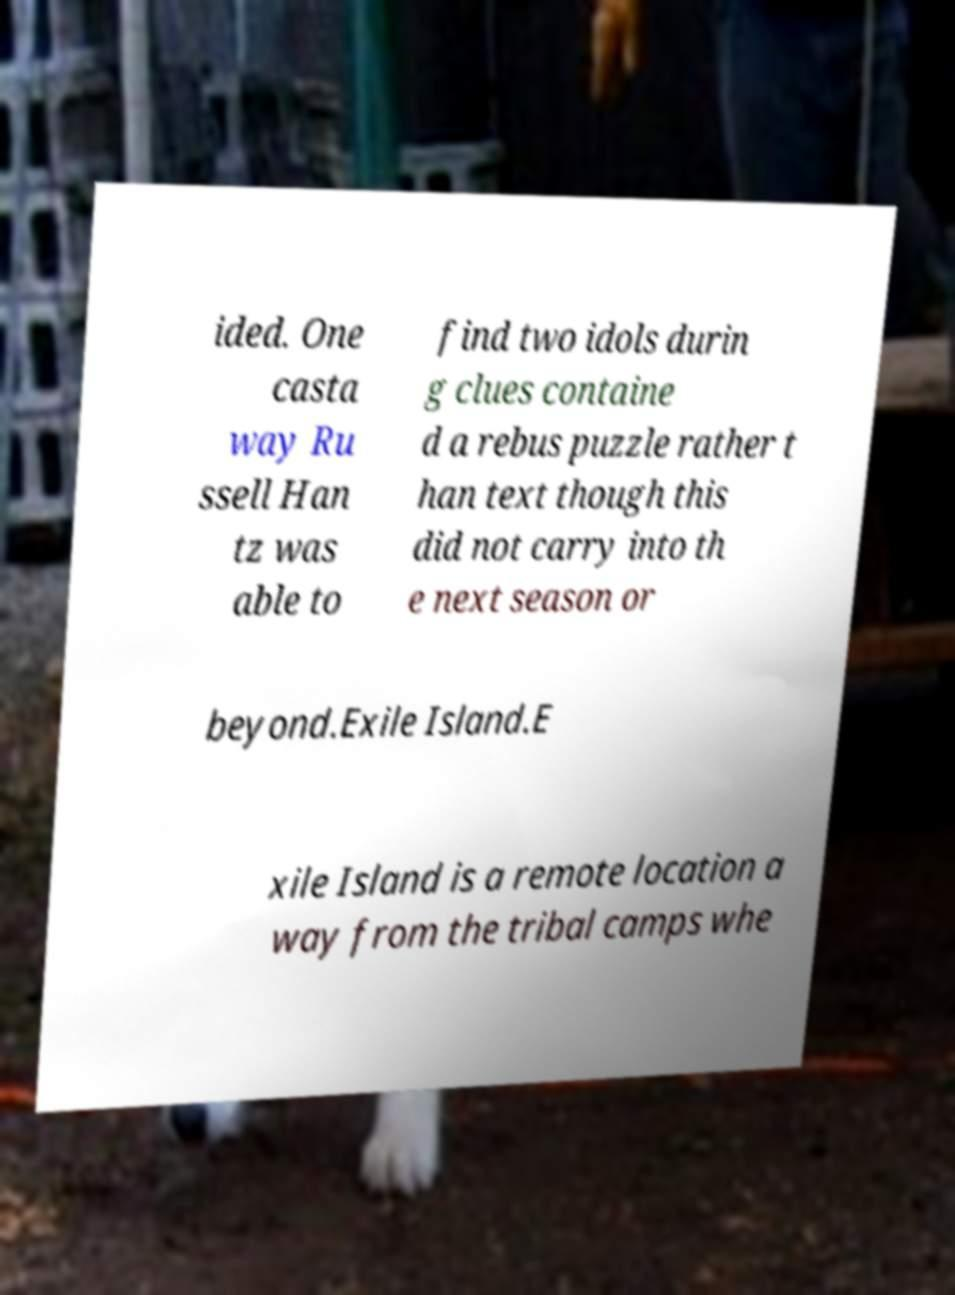I need the written content from this picture converted into text. Can you do that? ided. One casta way Ru ssell Han tz was able to find two idols durin g clues containe d a rebus puzzle rather t han text though this did not carry into th e next season or beyond.Exile Island.E xile Island is a remote location a way from the tribal camps whe 